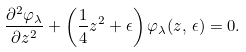Convert formula to latex. <formula><loc_0><loc_0><loc_500><loc_500>\frac { \partial ^ { 2 } \varphi _ { \lambda } } { \partial z ^ { 2 } } + \left ( \frac { 1 } { 4 } z ^ { 2 } + \epsilon \right ) \varphi _ { \lambda } ( z , \, \epsilon ) = 0 .</formula> 